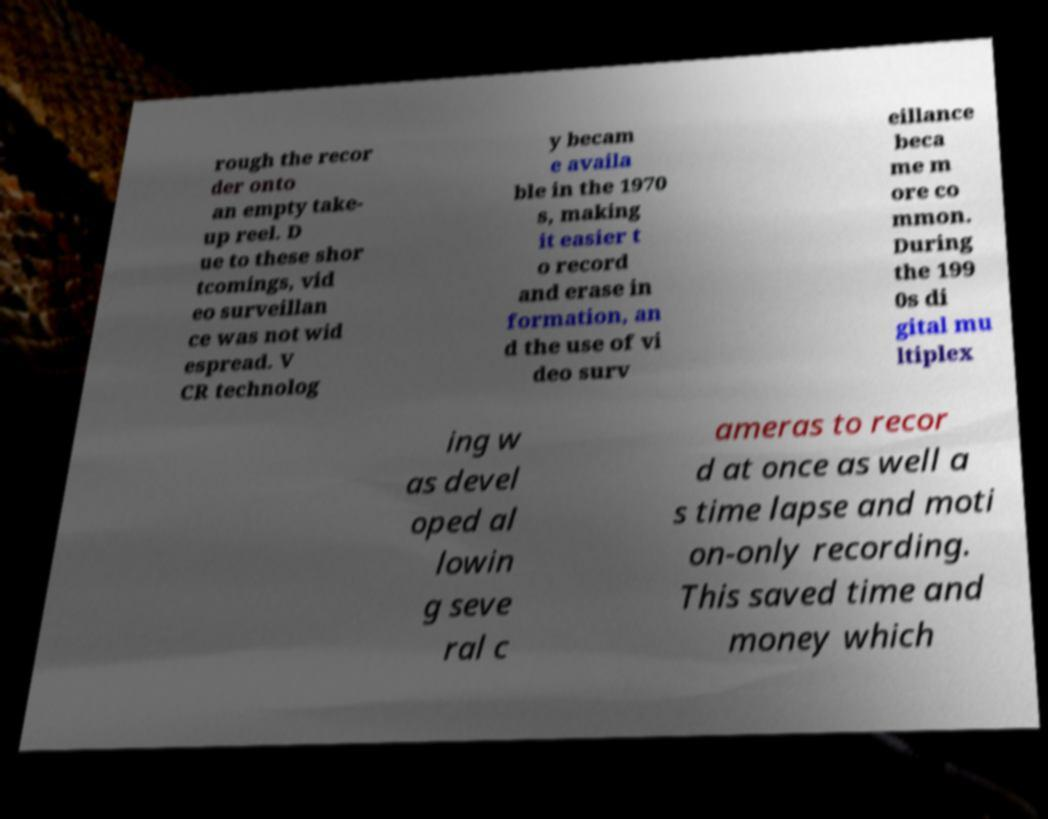There's text embedded in this image that I need extracted. Can you transcribe it verbatim? rough the recor der onto an empty take- up reel. D ue to these shor tcomings, vid eo surveillan ce was not wid espread. V CR technolog y becam e availa ble in the 1970 s, making it easier t o record and erase in formation, an d the use of vi deo surv eillance beca me m ore co mmon. During the 199 0s di gital mu ltiplex ing w as devel oped al lowin g seve ral c ameras to recor d at once as well a s time lapse and moti on-only recording. This saved time and money which 